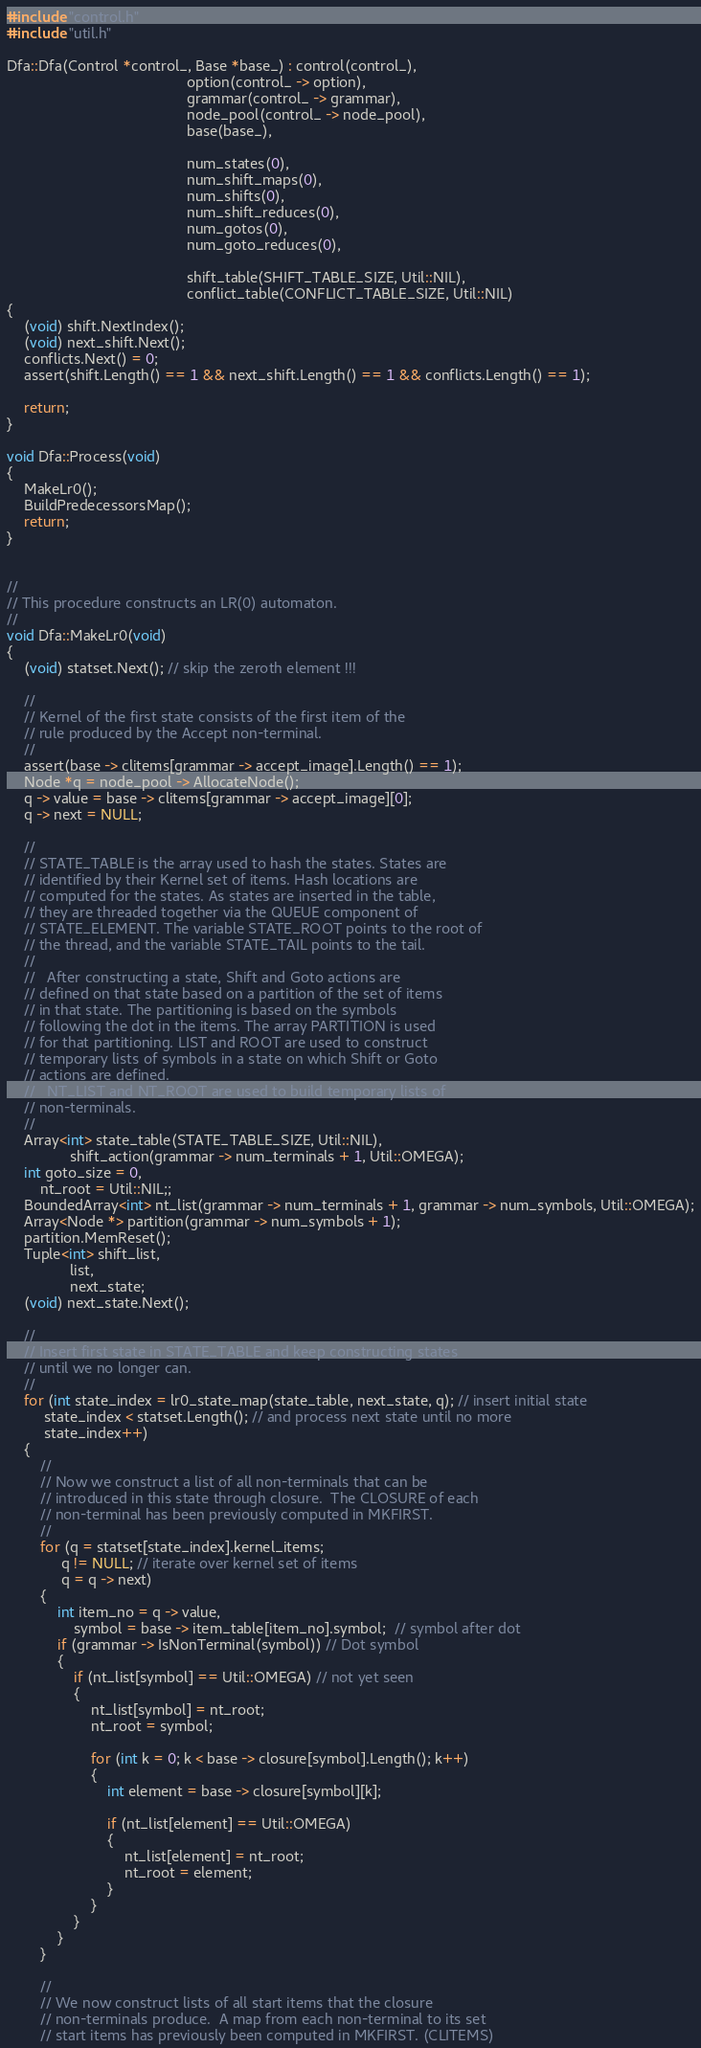<code> <loc_0><loc_0><loc_500><loc_500><_C++_>#include "control.h"
#include "util.h"

Dfa::Dfa(Control *control_, Base *base_) : control(control_),
                                           option(control_ -> option),
                                           grammar(control_ -> grammar),
                                           node_pool(control_ -> node_pool),
                                           base(base_),

                                           num_states(0),
                                           num_shift_maps(0),
                                           num_shifts(0),
                                           num_shift_reduces(0),
                                           num_gotos(0),
                                           num_goto_reduces(0),

                                           shift_table(SHIFT_TABLE_SIZE, Util::NIL),
                                           conflict_table(CONFLICT_TABLE_SIZE, Util::NIL)
{
    (void) shift.NextIndex();
    (void) next_shift.Next();
    conflicts.Next() = 0;
    assert(shift.Length() == 1 && next_shift.Length() == 1 && conflicts.Length() == 1);

    return;
}

void Dfa::Process(void)
{
    MakeLr0();
    BuildPredecessorsMap();
    return;
}


//
// This procedure constructs an LR(0) automaton.
//
void Dfa::MakeLr0(void)
{
    (void) statset.Next(); // skip the zeroth element !!!

    //
    // Kernel of the first state consists of the first item of the
    // rule produced by the Accept non-terminal.
    //
    assert(base -> clitems[grammar -> accept_image].Length() == 1);
    Node *q = node_pool -> AllocateNode();
    q -> value = base -> clitems[grammar -> accept_image][0];
    q -> next = NULL;

    //
    // STATE_TABLE is the array used to hash the states. States are
    // identified by their Kernel set of items. Hash locations are
    // computed for the states. As states are inserted in the table,
    // they are threaded together via the QUEUE component of
    // STATE_ELEMENT. The variable STATE_ROOT points to the root of
    // the thread, and the variable STATE_TAIL points to the tail.
    //
    //   After constructing a state, Shift and Goto actions are
    // defined on that state based on a partition of the set of items
    // in that state. The partitioning is based on the symbols
    // following the dot in the items. The array PARTITION is used
    // for that partitioning. LIST and ROOT are used to construct
    // temporary lists of symbols in a state on which Shift or Goto
    // actions are defined.
    //   NT_LIST and NT_ROOT are used to build temporary lists of
    // non-terminals.
    //
    Array<int> state_table(STATE_TABLE_SIZE, Util::NIL),
               shift_action(grammar -> num_terminals + 1, Util::OMEGA);
    int goto_size = 0,
        nt_root = Util::NIL;;
    BoundedArray<int> nt_list(grammar -> num_terminals + 1, grammar -> num_symbols, Util::OMEGA);
    Array<Node *> partition(grammar -> num_symbols + 1);
    partition.MemReset();
    Tuple<int> shift_list,
               list,
               next_state;
    (void) next_state.Next();

    //
    // Insert first state in STATE_TABLE and keep constructing states
    // until we no longer can.
    //
    for (int state_index = lr0_state_map(state_table, next_state, q); // insert initial state
         state_index < statset.Length(); // and process next state until no more
         state_index++)
    {
        //
        // Now we construct a list of all non-terminals that can be
        // introduced in this state through closure.  The CLOSURE of each
        // non-terminal has been previously computed in MKFIRST.
        //
        for (q = statset[state_index].kernel_items;
             q != NULL; // iterate over kernel set of items
             q = q -> next)
        {
            int item_no = q -> value,
                symbol = base -> item_table[item_no].symbol;  // symbol after dot
            if (grammar -> IsNonTerminal(symbol)) // Dot symbol
            {
                if (nt_list[symbol] == Util::OMEGA) // not yet seen
                {
                    nt_list[symbol] = nt_root;
                    nt_root = symbol;

                    for (int k = 0; k < base -> closure[symbol].Length(); k++)
                    {
                        int element = base -> closure[symbol][k];

                        if (nt_list[element] == Util::OMEGA)
                        {
                            nt_list[element] = nt_root;
                            nt_root = element;
                        }
                    }
                }
            }
        }

        //
        // We now construct lists of all start items that the closure
        // non-terminals produce.  A map from each non-terminal to its set
        // start items has previously been computed in MKFIRST. (CLITEMS)</code> 